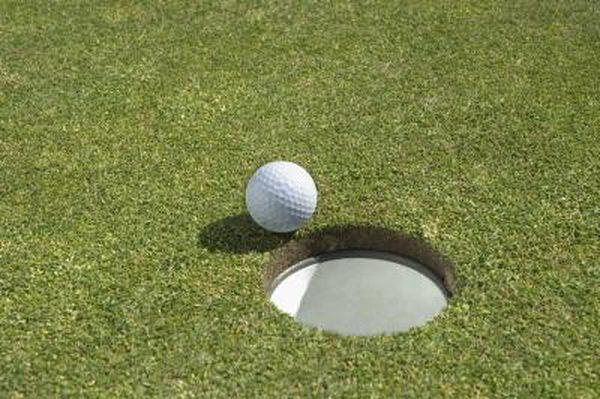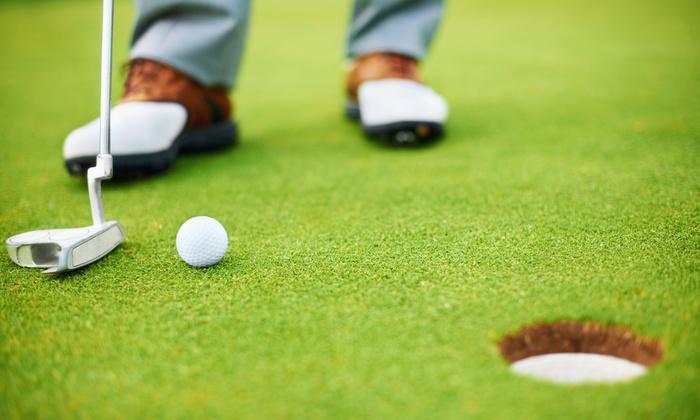The first image is the image on the left, the second image is the image on the right. Assess this claim about the two images: "There is at least two golf balls in the left image.". Correct or not? Answer yes or no. No. The first image is the image on the left, the second image is the image on the right. For the images shown, is this caption "A golf ball is within a ball's-width of a hole with no flag in it." true? Answer yes or no. Yes. 